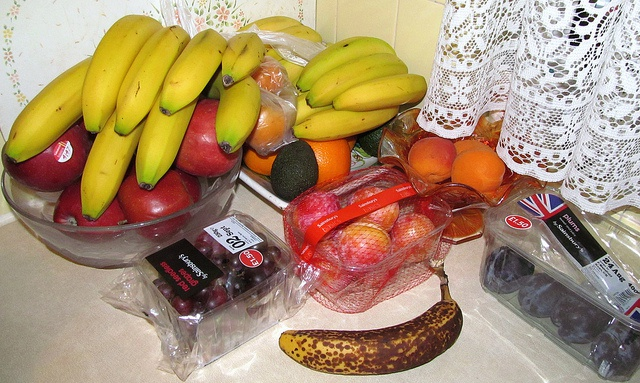Describe the objects in this image and their specific colors. I can see banana in lightgray, gold, and olive tones, apple in lightgray, maroon, brown, and black tones, banana in lightgray, maroon, brown, and black tones, apple in lightgray, red, salmon, and brown tones, and bowl in lightgray, gray, and maroon tones in this image. 